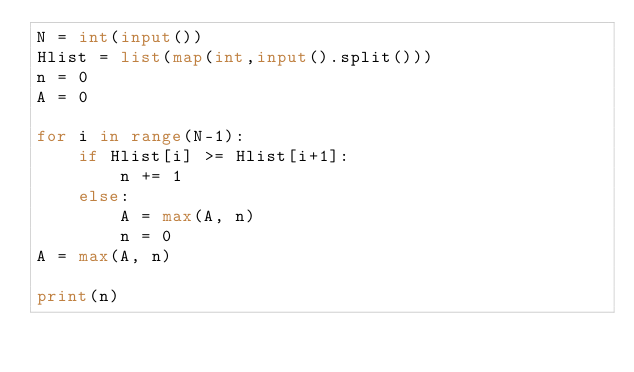Convert code to text. <code><loc_0><loc_0><loc_500><loc_500><_Python_>N = int(input())
Hlist = list(map(int,input().split()))
n = 0
A = 0

for i in range(N-1):
    if Hlist[i] >= Hlist[i+1]:
        n += 1
    else:
        A = max(A, n)
        n = 0
A = max(A, n)

print(n)</code> 